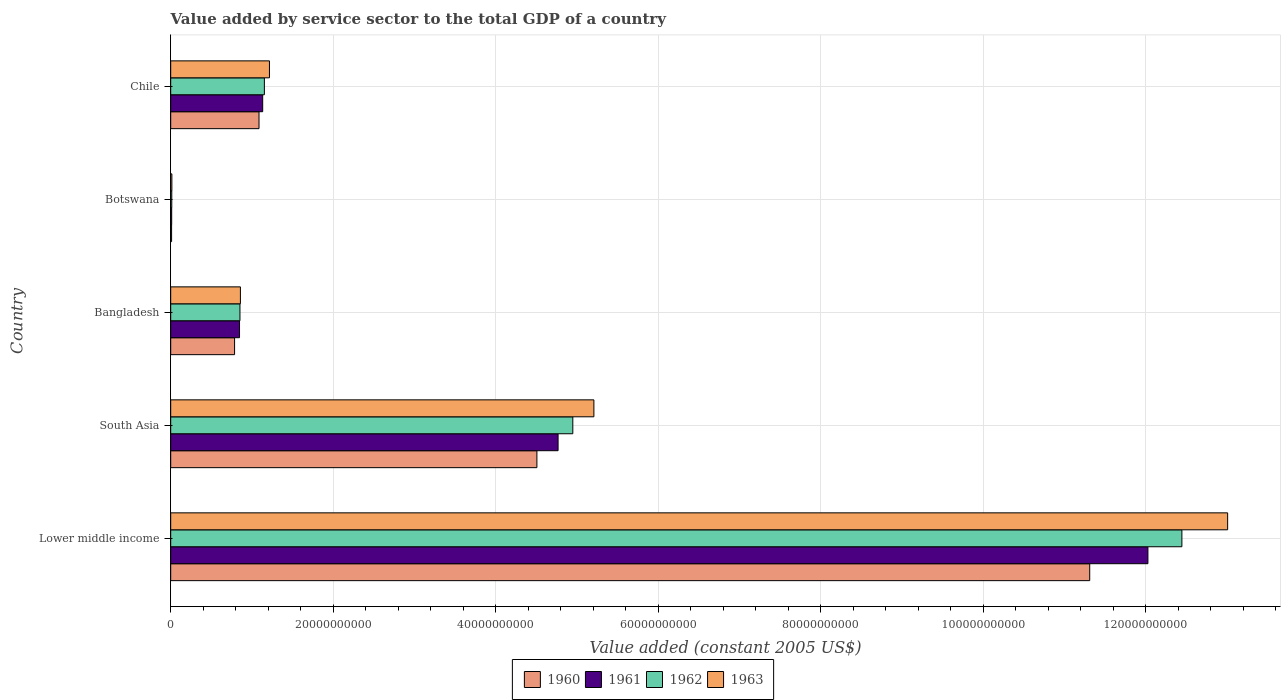How many different coloured bars are there?
Provide a short and direct response. 4. Are the number of bars per tick equal to the number of legend labels?
Make the answer very short. Yes. How many bars are there on the 4th tick from the top?
Offer a very short reply. 4. What is the label of the 2nd group of bars from the top?
Offer a very short reply. Botswana. What is the value added by service sector in 1960 in Chile?
Your response must be concise. 1.09e+1. Across all countries, what is the maximum value added by service sector in 1961?
Provide a succinct answer. 1.20e+11. Across all countries, what is the minimum value added by service sector in 1960?
Your answer should be very brief. 1.11e+08. In which country was the value added by service sector in 1960 maximum?
Offer a terse response. Lower middle income. In which country was the value added by service sector in 1963 minimum?
Offer a very short reply. Botswana. What is the total value added by service sector in 1962 in the graph?
Ensure brevity in your answer.  1.94e+11. What is the difference between the value added by service sector in 1962 in Lower middle income and that in South Asia?
Offer a very short reply. 7.50e+1. What is the difference between the value added by service sector in 1961 in Botswana and the value added by service sector in 1960 in Bangladesh?
Your answer should be compact. -7.74e+09. What is the average value added by service sector in 1963 per country?
Provide a succinct answer. 4.06e+1. What is the difference between the value added by service sector in 1960 and value added by service sector in 1963 in Chile?
Your response must be concise. -1.29e+09. In how many countries, is the value added by service sector in 1960 greater than 100000000000 US$?
Make the answer very short. 1. What is the ratio of the value added by service sector in 1961 in Bangladesh to that in Chile?
Your answer should be compact. 0.75. Is the value added by service sector in 1961 in Bangladesh less than that in Chile?
Provide a succinct answer. Yes. Is the difference between the value added by service sector in 1960 in Chile and Lower middle income greater than the difference between the value added by service sector in 1963 in Chile and Lower middle income?
Your response must be concise. Yes. What is the difference between the highest and the second highest value added by service sector in 1960?
Give a very brief answer. 6.80e+1. What is the difference between the highest and the lowest value added by service sector in 1962?
Offer a terse response. 1.24e+11. In how many countries, is the value added by service sector in 1960 greater than the average value added by service sector in 1960 taken over all countries?
Give a very brief answer. 2. Is the sum of the value added by service sector in 1962 in Bangladesh and Botswana greater than the maximum value added by service sector in 1963 across all countries?
Offer a very short reply. No. Is it the case that in every country, the sum of the value added by service sector in 1963 and value added by service sector in 1961 is greater than the sum of value added by service sector in 1960 and value added by service sector in 1962?
Provide a short and direct response. No. What does the 3rd bar from the top in Botswana represents?
Make the answer very short. 1961. Is it the case that in every country, the sum of the value added by service sector in 1963 and value added by service sector in 1962 is greater than the value added by service sector in 1960?
Ensure brevity in your answer.  Yes. Are all the bars in the graph horizontal?
Your response must be concise. Yes. How many countries are there in the graph?
Your response must be concise. 5. Does the graph contain any zero values?
Make the answer very short. No. How many legend labels are there?
Your answer should be very brief. 4. How are the legend labels stacked?
Keep it short and to the point. Horizontal. What is the title of the graph?
Provide a short and direct response. Value added by service sector to the total GDP of a country. What is the label or title of the X-axis?
Provide a succinct answer. Value added (constant 2005 US$). What is the Value added (constant 2005 US$) of 1960 in Lower middle income?
Your response must be concise. 1.13e+11. What is the Value added (constant 2005 US$) of 1961 in Lower middle income?
Give a very brief answer. 1.20e+11. What is the Value added (constant 2005 US$) of 1962 in Lower middle income?
Your response must be concise. 1.24e+11. What is the Value added (constant 2005 US$) in 1963 in Lower middle income?
Offer a very short reply. 1.30e+11. What is the Value added (constant 2005 US$) of 1960 in South Asia?
Keep it short and to the point. 4.51e+1. What is the Value added (constant 2005 US$) of 1961 in South Asia?
Your response must be concise. 4.77e+1. What is the Value added (constant 2005 US$) in 1962 in South Asia?
Ensure brevity in your answer.  4.95e+1. What is the Value added (constant 2005 US$) of 1963 in South Asia?
Your response must be concise. 5.21e+1. What is the Value added (constant 2005 US$) of 1960 in Bangladesh?
Ensure brevity in your answer.  7.86e+09. What is the Value added (constant 2005 US$) in 1961 in Bangladesh?
Your response must be concise. 8.47e+09. What is the Value added (constant 2005 US$) of 1962 in Bangladesh?
Make the answer very short. 8.52e+09. What is the Value added (constant 2005 US$) in 1963 in Bangladesh?
Provide a short and direct response. 8.58e+09. What is the Value added (constant 2005 US$) in 1960 in Botswana?
Ensure brevity in your answer.  1.11e+08. What is the Value added (constant 2005 US$) of 1961 in Botswana?
Your response must be concise. 1.22e+08. What is the Value added (constant 2005 US$) of 1962 in Botswana?
Your response must be concise. 1.32e+08. What is the Value added (constant 2005 US$) of 1963 in Botswana?
Make the answer very short. 1.45e+08. What is the Value added (constant 2005 US$) of 1960 in Chile?
Make the answer very short. 1.09e+1. What is the Value added (constant 2005 US$) of 1961 in Chile?
Keep it short and to the point. 1.13e+1. What is the Value added (constant 2005 US$) in 1962 in Chile?
Provide a short and direct response. 1.15e+1. What is the Value added (constant 2005 US$) of 1963 in Chile?
Provide a succinct answer. 1.22e+1. Across all countries, what is the maximum Value added (constant 2005 US$) in 1960?
Give a very brief answer. 1.13e+11. Across all countries, what is the maximum Value added (constant 2005 US$) in 1961?
Make the answer very short. 1.20e+11. Across all countries, what is the maximum Value added (constant 2005 US$) in 1962?
Provide a short and direct response. 1.24e+11. Across all countries, what is the maximum Value added (constant 2005 US$) in 1963?
Keep it short and to the point. 1.30e+11. Across all countries, what is the minimum Value added (constant 2005 US$) of 1960?
Offer a very short reply. 1.11e+08. Across all countries, what is the minimum Value added (constant 2005 US$) of 1961?
Provide a short and direct response. 1.22e+08. Across all countries, what is the minimum Value added (constant 2005 US$) of 1962?
Keep it short and to the point. 1.32e+08. Across all countries, what is the minimum Value added (constant 2005 US$) in 1963?
Keep it short and to the point. 1.45e+08. What is the total Value added (constant 2005 US$) of 1960 in the graph?
Your answer should be compact. 1.77e+11. What is the total Value added (constant 2005 US$) in 1961 in the graph?
Provide a succinct answer. 1.88e+11. What is the total Value added (constant 2005 US$) of 1962 in the graph?
Offer a very short reply. 1.94e+11. What is the total Value added (constant 2005 US$) in 1963 in the graph?
Keep it short and to the point. 2.03e+11. What is the difference between the Value added (constant 2005 US$) of 1960 in Lower middle income and that in South Asia?
Your answer should be very brief. 6.80e+1. What is the difference between the Value added (constant 2005 US$) in 1961 in Lower middle income and that in South Asia?
Offer a very short reply. 7.26e+1. What is the difference between the Value added (constant 2005 US$) of 1962 in Lower middle income and that in South Asia?
Give a very brief answer. 7.50e+1. What is the difference between the Value added (constant 2005 US$) in 1963 in Lower middle income and that in South Asia?
Provide a succinct answer. 7.80e+1. What is the difference between the Value added (constant 2005 US$) in 1960 in Lower middle income and that in Bangladesh?
Provide a short and direct response. 1.05e+11. What is the difference between the Value added (constant 2005 US$) of 1961 in Lower middle income and that in Bangladesh?
Your response must be concise. 1.12e+11. What is the difference between the Value added (constant 2005 US$) of 1962 in Lower middle income and that in Bangladesh?
Your answer should be very brief. 1.16e+11. What is the difference between the Value added (constant 2005 US$) of 1963 in Lower middle income and that in Bangladesh?
Provide a short and direct response. 1.21e+11. What is the difference between the Value added (constant 2005 US$) of 1960 in Lower middle income and that in Botswana?
Give a very brief answer. 1.13e+11. What is the difference between the Value added (constant 2005 US$) in 1961 in Lower middle income and that in Botswana?
Provide a succinct answer. 1.20e+11. What is the difference between the Value added (constant 2005 US$) of 1962 in Lower middle income and that in Botswana?
Provide a short and direct response. 1.24e+11. What is the difference between the Value added (constant 2005 US$) of 1963 in Lower middle income and that in Botswana?
Make the answer very short. 1.30e+11. What is the difference between the Value added (constant 2005 US$) in 1960 in Lower middle income and that in Chile?
Your response must be concise. 1.02e+11. What is the difference between the Value added (constant 2005 US$) in 1961 in Lower middle income and that in Chile?
Give a very brief answer. 1.09e+11. What is the difference between the Value added (constant 2005 US$) of 1962 in Lower middle income and that in Chile?
Offer a very short reply. 1.13e+11. What is the difference between the Value added (constant 2005 US$) in 1963 in Lower middle income and that in Chile?
Your answer should be compact. 1.18e+11. What is the difference between the Value added (constant 2005 US$) of 1960 in South Asia and that in Bangladesh?
Your answer should be compact. 3.72e+1. What is the difference between the Value added (constant 2005 US$) of 1961 in South Asia and that in Bangladesh?
Offer a terse response. 3.92e+1. What is the difference between the Value added (constant 2005 US$) in 1962 in South Asia and that in Bangladesh?
Provide a succinct answer. 4.10e+1. What is the difference between the Value added (constant 2005 US$) of 1963 in South Asia and that in Bangladesh?
Give a very brief answer. 4.35e+1. What is the difference between the Value added (constant 2005 US$) of 1960 in South Asia and that in Botswana?
Your answer should be compact. 4.50e+1. What is the difference between the Value added (constant 2005 US$) in 1961 in South Asia and that in Botswana?
Keep it short and to the point. 4.75e+1. What is the difference between the Value added (constant 2005 US$) in 1962 in South Asia and that in Botswana?
Keep it short and to the point. 4.93e+1. What is the difference between the Value added (constant 2005 US$) of 1963 in South Asia and that in Botswana?
Provide a succinct answer. 5.19e+1. What is the difference between the Value added (constant 2005 US$) in 1960 in South Asia and that in Chile?
Your answer should be very brief. 3.42e+1. What is the difference between the Value added (constant 2005 US$) of 1961 in South Asia and that in Chile?
Your answer should be compact. 3.63e+1. What is the difference between the Value added (constant 2005 US$) of 1962 in South Asia and that in Chile?
Your answer should be very brief. 3.80e+1. What is the difference between the Value added (constant 2005 US$) of 1963 in South Asia and that in Chile?
Your response must be concise. 3.99e+1. What is the difference between the Value added (constant 2005 US$) of 1960 in Bangladesh and that in Botswana?
Offer a terse response. 7.75e+09. What is the difference between the Value added (constant 2005 US$) of 1961 in Bangladesh and that in Botswana?
Your answer should be compact. 8.35e+09. What is the difference between the Value added (constant 2005 US$) of 1962 in Bangladesh and that in Botswana?
Your answer should be compact. 8.39e+09. What is the difference between the Value added (constant 2005 US$) of 1963 in Bangladesh and that in Botswana?
Your response must be concise. 8.43e+09. What is the difference between the Value added (constant 2005 US$) of 1960 in Bangladesh and that in Chile?
Offer a terse response. -3.01e+09. What is the difference between the Value added (constant 2005 US$) of 1961 in Bangladesh and that in Chile?
Offer a very short reply. -2.85e+09. What is the difference between the Value added (constant 2005 US$) of 1962 in Bangladesh and that in Chile?
Your response must be concise. -3.00e+09. What is the difference between the Value added (constant 2005 US$) in 1963 in Bangladesh and that in Chile?
Give a very brief answer. -3.58e+09. What is the difference between the Value added (constant 2005 US$) in 1960 in Botswana and that in Chile?
Your answer should be very brief. -1.08e+1. What is the difference between the Value added (constant 2005 US$) of 1961 in Botswana and that in Chile?
Offer a very short reply. -1.12e+1. What is the difference between the Value added (constant 2005 US$) in 1962 in Botswana and that in Chile?
Provide a succinct answer. -1.14e+1. What is the difference between the Value added (constant 2005 US$) of 1963 in Botswana and that in Chile?
Provide a succinct answer. -1.20e+1. What is the difference between the Value added (constant 2005 US$) in 1960 in Lower middle income and the Value added (constant 2005 US$) in 1961 in South Asia?
Keep it short and to the point. 6.54e+1. What is the difference between the Value added (constant 2005 US$) in 1960 in Lower middle income and the Value added (constant 2005 US$) in 1962 in South Asia?
Provide a succinct answer. 6.36e+1. What is the difference between the Value added (constant 2005 US$) in 1960 in Lower middle income and the Value added (constant 2005 US$) in 1963 in South Asia?
Your response must be concise. 6.10e+1. What is the difference between the Value added (constant 2005 US$) in 1961 in Lower middle income and the Value added (constant 2005 US$) in 1962 in South Asia?
Give a very brief answer. 7.08e+1. What is the difference between the Value added (constant 2005 US$) of 1961 in Lower middle income and the Value added (constant 2005 US$) of 1963 in South Asia?
Your answer should be compact. 6.82e+1. What is the difference between the Value added (constant 2005 US$) of 1962 in Lower middle income and the Value added (constant 2005 US$) of 1963 in South Asia?
Your answer should be compact. 7.24e+1. What is the difference between the Value added (constant 2005 US$) in 1960 in Lower middle income and the Value added (constant 2005 US$) in 1961 in Bangladesh?
Provide a short and direct response. 1.05e+11. What is the difference between the Value added (constant 2005 US$) in 1960 in Lower middle income and the Value added (constant 2005 US$) in 1962 in Bangladesh?
Give a very brief answer. 1.05e+11. What is the difference between the Value added (constant 2005 US$) in 1960 in Lower middle income and the Value added (constant 2005 US$) in 1963 in Bangladesh?
Your answer should be compact. 1.05e+11. What is the difference between the Value added (constant 2005 US$) of 1961 in Lower middle income and the Value added (constant 2005 US$) of 1962 in Bangladesh?
Make the answer very short. 1.12e+11. What is the difference between the Value added (constant 2005 US$) in 1961 in Lower middle income and the Value added (constant 2005 US$) in 1963 in Bangladesh?
Keep it short and to the point. 1.12e+11. What is the difference between the Value added (constant 2005 US$) of 1962 in Lower middle income and the Value added (constant 2005 US$) of 1963 in Bangladesh?
Offer a terse response. 1.16e+11. What is the difference between the Value added (constant 2005 US$) in 1960 in Lower middle income and the Value added (constant 2005 US$) in 1961 in Botswana?
Give a very brief answer. 1.13e+11. What is the difference between the Value added (constant 2005 US$) of 1960 in Lower middle income and the Value added (constant 2005 US$) of 1962 in Botswana?
Provide a short and direct response. 1.13e+11. What is the difference between the Value added (constant 2005 US$) of 1960 in Lower middle income and the Value added (constant 2005 US$) of 1963 in Botswana?
Your response must be concise. 1.13e+11. What is the difference between the Value added (constant 2005 US$) of 1961 in Lower middle income and the Value added (constant 2005 US$) of 1962 in Botswana?
Your answer should be compact. 1.20e+11. What is the difference between the Value added (constant 2005 US$) in 1961 in Lower middle income and the Value added (constant 2005 US$) in 1963 in Botswana?
Offer a very short reply. 1.20e+11. What is the difference between the Value added (constant 2005 US$) in 1962 in Lower middle income and the Value added (constant 2005 US$) in 1963 in Botswana?
Keep it short and to the point. 1.24e+11. What is the difference between the Value added (constant 2005 US$) in 1960 in Lower middle income and the Value added (constant 2005 US$) in 1961 in Chile?
Provide a short and direct response. 1.02e+11. What is the difference between the Value added (constant 2005 US$) in 1960 in Lower middle income and the Value added (constant 2005 US$) in 1962 in Chile?
Ensure brevity in your answer.  1.02e+11. What is the difference between the Value added (constant 2005 US$) in 1960 in Lower middle income and the Value added (constant 2005 US$) in 1963 in Chile?
Offer a very short reply. 1.01e+11. What is the difference between the Value added (constant 2005 US$) of 1961 in Lower middle income and the Value added (constant 2005 US$) of 1962 in Chile?
Provide a short and direct response. 1.09e+11. What is the difference between the Value added (constant 2005 US$) in 1961 in Lower middle income and the Value added (constant 2005 US$) in 1963 in Chile?
Your response must be concise. 1.08e+11. What is the difference between the Value added (constant 2005 US$) in 1962 in Lower middle income and the Value added (constant 2005 US$) in 1963 in Chile?
Give a very brief answer. 1.12e+11. What is the difference between the Value added (constant 2005 US$) of 1960 in South Asia and the Value added (constant 2005 US$) of 1961 in Bangladesh?
Your answer should be compact. 3.66e+1. What is the difference between the Value added (constant 2005 US$) of 1960 in South Asia and the Value added (constant 2005 US$) of 1962 in Bangladesh?
Offer a terse response. 3.65e+1. What is the difference between the Value added (constant 2005 US$) of 1960 in South Asia and the Value added (constant 2005 US$) of 1963 in Bangladesh?
Your response must be concise. 3.65e+1. What is the difference between the Value added (constant 2005 US$) in 1961 in South Asia and the Value added (constant 2005 US$) in 1962 in Bangladesh?
Your response must be concise. 3.91e+1. What is the difference between the Value added (constant 2005 US$) in 1961 in South Asia and the Value added (constant 2005 US$) in 1963 in Bangladesh?
Your answer should be very brief. 3.91e+1. What is the difference between the Value added (constant 2005 US$) of 1962 in South Asia and the Value added (constant 2005 US$) of 1963 in Bangladesh?
Offer a terse response. 4.09e+1. What is the difference between the Value added (constant 2005 US$) of 1960 in South Asia and the Value added (constant 2005 US$) of 1961 in Botswana?
Offer a very short reply. 4.49e+1. What is the difference between the Value added (constant 2005 US$) of 1960 in South Asia and the Value added (constant 2005 US$) of 1962 in Botswana?
Your answer should be compact. 4.49e+1. What is the difference between the Value added (constant 2005 US$) of 1960 in South Asia and the Value added (constant 2005 US$) of 1963 in Botswana?
Your answer should be very brief. 4.49e+1. What is the difference between the Value added (constant 2005 US$) of 1961 in South Asia and the Value added (constant 2005 US$) of 1962 in Botswana?
Keep it short and to the point. 4.75e+1. What is the difference between the Value added (constant 2005 US$) in 1961 in South Asia and the Value added (constant 2005 US$) in 1963 in Botswana?
Give a very brief answer. 4.75e+1. What is the difference between the Value added (constant 2005 US$) of 1962 in South Asia and the Value added (constant 2005 US$) of 1963 in Botswana?
Provide a succinct answer. 4.93e+1. What is the difference between the Value added (constant 2005 US$) of 1960 in South Asia and the Value added (constant 2005 US$) of 1961 in Chile?
Provide a short and direct response. 3.37e+1. What is the difference between the Value added (constant 2005 US$) in 1960 in South Asia and the Value added (constant 2005 US$) in 1962 in Chile?
Your answer should be very brief. 3.35e+1. What is the difference between the Value added (constant 2005 US$) in 1960 in South Asia and the Value added (constant 2005 US$) in 1963 in Chile?
Your answer should be very brief. 3.29e+1. What is the difference between the Value added (constant 2005 US$) in 1961 in South Asia and the Value added (constant 2005 US$) in 1962 in Chile?
Offer a very short reply. 3.61e+1. What is the difference between the Value added (constant 2005 US$) of 1961 in South Asia and the Value added (constant 2005 US$) of 1963 in Chile?
Your answer should be compact. 3.55e+1. What is the difference between the Value added (constant 2005 US$) in 1962 in South Asia and the Value added (constant 2005 US$) in 1963 in Chile?
Your answer should be compact. 3.73e+1. What is the difference between the Value added (constant 2005 US$) of 1960 in Bangladesh and the Value added (constant 2005 US$) of 1961 in Botswana?
Keep it short and to the point. 7.74e+09. What is the difference between the Value added (constant 2005 US$) in 1960 in Bangladesh and the Value added (constant 2005 US$) in 1962 in Botswana?
Make the answer very short. 7.73e+09. What is the difference between the Value added (constant 2005 US$) of 1960 in Bangladesh and the Value added (constant 2005 US$) of 1963 in Botswana?
Give a very brief answer. 7.72e+09. What is the difference between the Value added (constant 2005 US$) of 1961 in Bangladesh and the Value added (constant 2005 US$) of 1962 in Botswana?
Ensure brevity in your answer.  8.34e+09. What is the difference between the Value added (constant 2005 US$) in 1961 in Bangladesh and the Value added (constant 2005 US$) in 1963 in Botswana?
Your answer should be very brief. 8.32e+09. What is the difference between the Value added (constant 2005 US$) of 1962 in Bangladesh and the Value added (constant 2005 US$) of 1963 in Botswana?
Offer a very short reply. 8.38e+09. What is the difference between the Value added (constant 2005 US$) of 1960 in Bangladesh and the Value added (constant 2005 US$) of 1961 in Chile?
Ensure brevity in your answer.  -3.46e+09. What is the difference between the Value added (constant 2005 US$) in 1960 in Bangladesh and the Value added (constant 2005 US$) in 1962 in Chile?
Provide a succinct answer. -3.67e+09. What is the difference between the Value added (constant 2005 US$) of 1960 in Bangladesh and the Value added (constant 2005 US$) of 1963 in Chile?
Provide a succinct answer. -4.29e+09. What is the difference between the Value added (constant 2005 US$) in 1961 in Bangladesh and the Value added (constant 2005 US$) in 1962 in Chile?
Provide a succinct answer. -3.06e+09. What is the difference between the Value added (constant 2005 US$) in 1961 in Bangladesh and the Value added (constant 2005 US$) in 1963 in Chile?
Your answer should be compact. -3.68e+09. What is the difference between the Value added (constant 2005 US$) of 1962 in Bangladesh and the Value added (constant 2005 US$) of 1963 in Chile?
Your response must be concise. -3.63e+09. What is the difference between the Value added (constant 2005 US$) of 1960 in Botswana and the Value added (constant 2005 US$) of 1961 in Chile?
Provide a succinct answer. -1.12e+1. What is the difference between the Value added (constant 2005 US$) in 1960 in Botswana and the Value added (constant 2005 US$) in 1962 in Chile?
Your answer should be compact. -1.14e+1. What is the difference between the Value added (constant 2005 US$) in 1960 in Botswana and the Value added (constant 2005 US$) in 1963 in Chile?
Provide a succinct answer. -1.20e+1. What is the difference between the Value added (constant 2005 US$) of 1961 in Botswana and the Value added (constant 2005 US$) of 1962 in Chile?
Provide a succinct answer. -1.14e+1. What is the difference between the Value added (constant 2005 US$) of 1961 in Botswana and the Value added (constant 2005 US$) of 1963 in Chile?
Provide a succinct answer. -1.20e+1. What is the difference between the Value added (constant 2005 US$) of 1962 in Botswana and the Value added (constant 2005 US$) of 1963 in Chile?
Your answer should be compact. -1.20e+1. What is the average Value added (constant 2005 US$) in 1960 per country?
Make the answer very short. 3.54e+1. What is the average Value added (constant 2005 US$) of 1961 per country?
Ensure brevity in your answer.  3.76e+1. What is the average Value added (constant 2005 US$) of 1962 per country?
Your response must be concise. 3.88e+1. What is the average Value added (constant 2005 US$) of 1963 per country?
Your response must be concise. 4.06e+1. What is the difference between the Value added (constant 2005 US$) in 1960 and Value added (constant 2005 US$) in 1961 in Lower middle income?
Provide a short and direct response. -7.16e+09. What is the difference between the Value added (constant 2005 US$) of 1960 and Value added (constant 2005 US$) of 1962 in Lower middle income?
Your answer should be very brief. -1.13e+1. What is the difference between the Value added (constant 2005 US$) in 1960 and Value added (constant 2005 US$) in 1963 in Lower middle income?
Offer a very short reply. -1.70e+1. What is the difference between the Value added (constant 2005 US$) of 1961 and Value added (constant 2005 US$) of 1962 in Lower middle income?
Provide a succinct answer. -4.18e+09. What is the difference between the Value added (constant 2005 US$) in 1961 and Value added (constant 2005 US$) in 1963 in Lower middle income?
Give a very brief answer. -9.81e+09. What is the difference between the Value added (constant 2005 US$) of 1962 and Value added (constant 2005 US$) of 1963 in Lower middle income?
Your response must be concise. -5.63e+09. What is the difference between the Value added (constant 2005 US$) in 1960 and Value added (constant 2005 US$) in 1961 in South Asia?
Make the answer very short. -2.61e+09. What is the difference between the Value added (constant 2005 US$) of 1960 and Value added (constant 2005 US$) of 1962 in South Asia?
Ensure brevity in your answer.  -4.42e+09. What is the difference between the Value added (constant 2005 US$) of 1960 and Value added (constant 2005 US$) of 1963 in South Asia?
Your answer should be compact. -7.01e+09. What is the difference between the Value added (constant 2005 US$) in 1961 and Value added (constant 2005 US$) in 1962 in South Asia?
Your answer should be compact. -1.81e+09. What is the difference between the Value added (constant 2005 US$) in 1961 and Value added (constant 2005 US$) in 1963 in South Asia?
Offer a very short reply. -4.41e+09. What is the difference between the Value added (constant 2005 US$) of 1962 and Value added (constant 2005 US$) of 1963 in South Asia?
Offer a very short reply. -2.59e+09. What is the difference between the Value added (constant 2005 US$) of 1960 and Value added (constant 2005 US$) of 1961 in Bangladesh?
Give a very brief answer. -6.09e+08. What is the difference between the Value added (constant 2005 US$) of 1960 and Value added (constant 2005 US$) of 1962 in Bangladesh?
Offer a very short reply. -6.62e+08. What is the difference between the Value added (constant 2005 US$) in 1960 and Value added (constant 2005 US$) in 1963 in Bangladesh?
Offer a very short reply. -7.16e+08. What is the difference between the Value added (constant 2005 US$) in 1961 and Value added (constant 2005 US$) in 1962 in Bangladesh?
Provide a succinct answer. -5.33e+07. What is the difference between the Value added (constant 2005 US$) in 1961 and Value added (constant 2005 US$) in 1963 in Bangladesh?
Your answer should be compact. -1.08e+08. What is the difference between the Value added (constant 2005 US$) of 1962 and Value added (constant 2005 US$) of 1963 in Bangladesh?
Your response must be concise. -5.45e+07. What is the difference between the Value added (constant 2005 US$) of 1960 and Value added (constant 2005 US$) of 1961 in Botswana?
Keep it short and to the point. -1.12e+07. What is the difference between the Value added (constant 2005 US$) in 1960 and Value added (constant 2005 US$) in 1962 in Botswana?
Offer a very short reply. -2.17e+07. What is the difference between the Value added (constant 2005 US$) of 1960 and Value added (constant 2005 US$) of 1963 in Botswana?
Make the answer very short. -3.45e+07. What is the difference between the Value added (constant 2005 US$) in 1961 and Value added (constant 2005 US$) in 1962 in Botswana?
Make the answer very short. -1.05e+07. What is the difference between the Value added (constant 2005 US$) of 1961 and Value added (constant 2005 US$) of 1963 in Botswana?
Provide a short and direct response. -2.33e+07. What is the difference between the Value added (constant 2005 US$) of 1962 and Value added (constant 2005 US$) of 1963 in Botswana?
Make the answer very short. -1.28e+07. What is the difference between the Value added (constant 2005 US$) of 1960 and Value added (constant 2005 US$) of 1961 in Chile?
Ensure brevity in your answer.  -4.53e+08. What is the difference between the Value added (constant 2005 US$) of 1960 and Value added (constant 2005 US$) of 1962 in Chile?
Ensure brevity in your answer.  -6.60e+08. What is the difference between the Value added (constant 2005 US$) in 1960 and Value added (constant 2005 US$) in 1963 in Chile?
Provide a succinct answer. -1.29e+09. What is the difference between the Value added (constant 2005 US$) of 1961 and Value added (constant 2005 US$) of 1962 in Chile?
Give a very brief answer. -2.07e+08. What is the difference between the Value added (constant 2005 US$) in 1961 and Value added (constant 2005 US$) in 1963 in Chile?
Ensure brevity in your answer.  -8.32e+08. What is the difference between the Value added (constant 2005 US$) of 1962 and Value added (constant 2005 US$) of 1963 in Chile?
Offer a very short reply. -6.25e+08. What is the ratio of the Value added (constant 2005 US$) of 1960 in Lower middle income to that in South Asia?
Your answer should be compact. 2.51. What is the ratio of the Value added (constant 2005 US$) in 1961 in Lower middle income to that in South Asia?
Offer a very short reply. 2.52. What is the ratio of the Value added (constant 2005 US$) in 1962 in Lower middle income to that in South Asia?
Your response must be concise. 2.51. What is the ratio of the Value added (constant 2005 US$) of 1963 in Lower middle income to that in South Asia?
Provide a short and direct response. 2.5. What is the ratio of the Value added (constant 2005 US$) of 1960 in Lower middle income to that in Bangladesh?
Your answer should be very brief. 14.39. What is the ratio of the Value added (constant 2005 US$) of 1961 in Lower middle income to that in Bangladesh?
Your answer should be very brief. 14.2. What is the ratio of the Value added (constant 2005 US$) of 1962 in Lower middle income to that in Bangladesh?
Keep it short and to the point. 14.6. What is the ratio of the Value added (constant 2005 US$) in 1963 in Lower middle income to that in Bangladesh?
Your answer should be very brief. 15.16. What is the ratio of the Value added (constant 2005 US$) in 1960 in Lower middle income to that in Botswana?
Offer a very short reply. 1022.68. What is the ratio of the Value added (constant 2005 US$) in 1961 in Lower middle income to that in Botswana?
Provide a short and direct response. 987.49. What is the ratio of the Value added (constant 2005 US$) of 1962 in Lower middle income to that in Botswana?
Offer a terse response. 940.71. What is the ratio of the Value added (constant 2005 US$) in 1963 in Lower middle income to that in Botswana?
Your answer should be very brief. 896.5. What is the ratio of the Value added (constant 2005 US$) in 1960 in Lower middle income to that in Chile?
Your answer should be compact. 10.41. What is the ratio of the Value added (constant 2005 US$) of 1961 in Lower middle income to that in Chile?
Provide a short and direct response. 10.62. What is the ratio of the Value added (constant 2005 US$) of 1962 in Lower middle income to that in Chile?
Your response must be concise. 10.79. What is the ratio of the Value added (constant 2005 US$) of 1963 in Lower middle income to that in Chile?
Provide a succinct answer. 10.7. What is the ratio of the Value added (constant 2005 US$) in 1960 in South Asia to that in Bangladesh?
Your answer should be compact. 5.73. What is the ratio of the Value added (constant 2005 US$) of 1961 in South Asia to that in Bangladesh?
Provide a succinct answer. 5.63. What is the ratio of the Value added (constant 2005 US$) in 1962 in South Asia to that in Bangladesh?
Your response must be concise. 5.81. What is the ratio of the Value added (constant 2005 US$) of 1963 in South Asia to that in Bangladesh?
Keep it short and to the point. 6.07. What is the ratio of the Value added (constant 2005 US$) in 1960 in South Asia to that in Botswana?
Provide a succinct answer. 407.52. What is the ratio of the Value added (constant 2005 US$) of 1961 in South Asia to that in Botswana?
Ensure brevity in your answer.  391.45. What is the ratio of the Value added (constant 2005 US$) in 1962 in South Asia to that in Botswana?
Make the answer very short. 374.08. What is the ratio of the Value added (constant 2005 US$) of 1963 in South Asia to that in Botswana?
Your answer should be compact. 358.96. What is the ratio of the Value added (constant 2005 US$) in 1960 in South Asia to that in Chile?
Keep it short and to the point. 4.15. What is the ratio of the Value added (constant 2005 US$) of 1961 in South Asia to that in Chile?
Ensure brevity in your answer.  4.21. What is the ratio of the Value added (constant 2005 US$) of 1962 in South Asia to that in Chile?
Make the answer very short. 4.29. What is the ratio of the Value added (constant 2005 US$) in 1963 in South Asia to that in Chile?
Provide a short and direct response. 4.29. What is the ratio of the Value added (constant 2005 US$) of 1960 in Bangladesh to that in Botswana?
Offer a terse response. 71.09. What is the ratio of the Value added (constant 2005 US$) in 1961 in Bangladesh to that in Botswana?
Keep it short and to the point. 69.55. What is the ratio of the Value added (constant 2005 US$) in 1962 in Bangladesh to that in Botswana?
Make the answer very short. 64.43. What is the ratio of the Value added (constant 2005 US$) of 1963 in Bangladesh to that in Botswana?
Your answer should be compact. 59.12. What is the ratio of the Value added (constant 2005 US$) of 1960 in Bangladesh to that in Chile?
Your answer should be very brief. 0.72. What is the ratio of the Value added (constant 2005 US$) in 1961 in Bangladesh to that in Chile?
Keep it short and to the point. 0.75. What is the ratio of the Value added (constant 2005 US$) in 1962 in Bangladesh to that in Chile?
Offer a very short reply. 0.74. What is the ratio of the Value added (constant 2005 US$) in 1963 in Bangladesh to that in Chile?
Your answer should be compact. 0.71. What is the ratio of the Value added (constant 2005 US$) in 1960 in Botswana to that in Chile?
Your answer should be very brief. 0.01. What is the ratio of the Value added (constant 2005 US$) of 1961 in Botswana to that in Chile?
Your answer should be very brief. 0.01. What is the ratio of the Value added (constant 2005 US$) of 1962 in Botswana to that in Chile?
Keep it short and to the point. 0.01. What is the ratio of the Value added (constant 2005 US$) in 1963 in Botswana to that in Chile?
Your response must be concise. 0.01. What is the difference between the highest and the second highest Value added (constant 2005 US$) in 1960?
Your response must be concise. 6.80e+1. What is the difference between the highest and the second highest Value added (constant 2005 US$) in 1961?
Your response must be concise. 7.26e+1. What is the difference between the highest and the second highest Value added (constant 2005 US$) in 1962?
Provide a short and direct response. 7.50e+1. What is the difference between the highest and the second highest Value added (constant 2005 US$) in 1963?
Make the answer very short. 7.80e+1. What is the difference between the highest and the lowest Value added (constant 2005 US$) of 1960?
Keep it short and to the point. 1.13e+11. What is the difference between the highest and the lowest Value added (constant 2005 US$) in 1961?
Ensure brevity in your answer.  1.20e+11. What is the difference between the highest and the lowest Value added (constant 2005 US$) of 1962?
Keep it short and to the point. 1.24e+11. What is the difference between the highest and the lowest Value added (constant 2005 US$) in 1963?
Make the answer very short. 1.30e+11. 